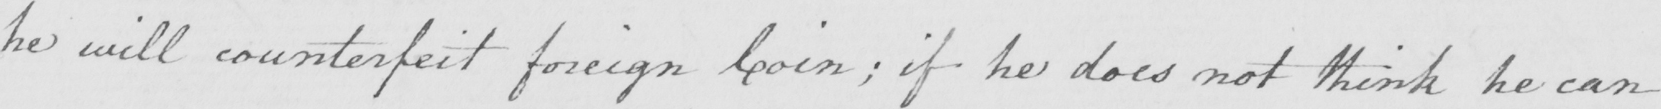Can you read and transcribe this handwriting? he will counterfeit foreign Coin ; if he does not think he can 